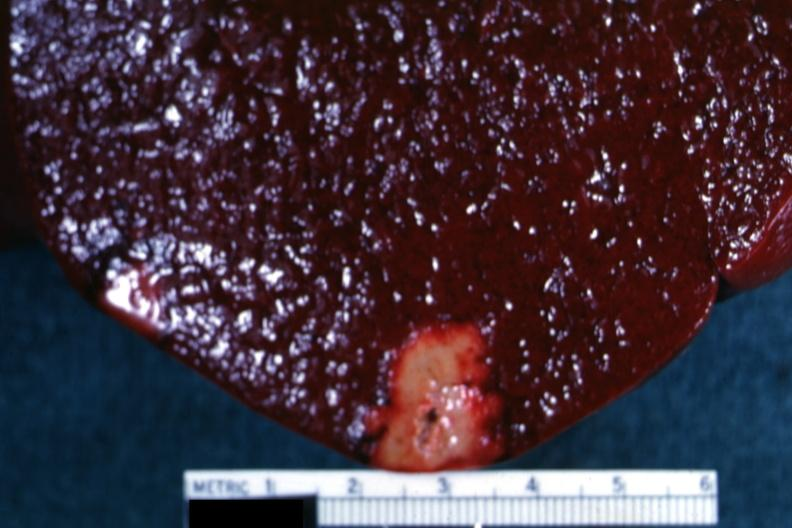how does this image show yellow infarct?
Answer the question using a single word or phrase. With band of reactive hyperemia 